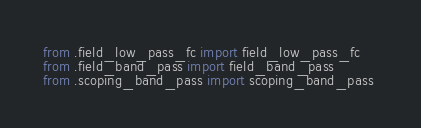<code> <loc_0><loc_0><loc_500><loc_500><_Python_>from .field_low_pass_fc import field_low_pass_fc 
from .field_band_pass import field_band_pass 
from .scoping_band_pass import scoping_band_pass 
</code> 